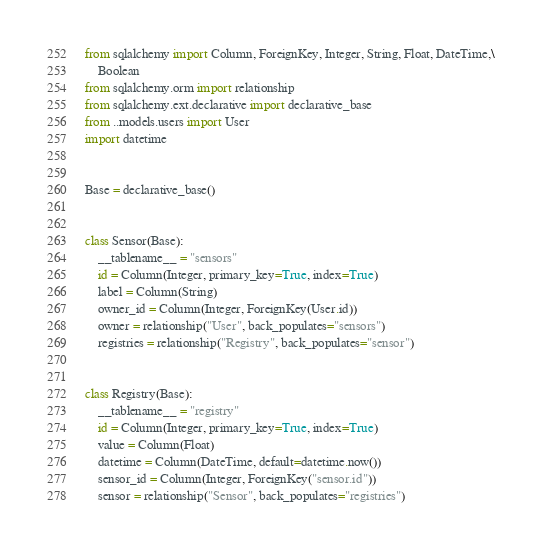Convert code to text. <code><loc_0><loc_0><loc_500><loc_500><_Python_>from sqlalchemy import Column, ForeignKey, Integer, String, Float, DateTime,\
    Boolean
from sqlalchemy.orm import relationship
from sqlalchemy.ext.declarative import declarative_base
from ..models.users import User
import datetime


Base = declarative_base()


class Sensor(Base):
    __tablename__ = "sensors"
    id = Column(Integer, primary_key=True, index=True)
    label = Column(String)
    owner_id = Column(Integer, ForeignKey(User.id))
    owner = relationship("User", back_populates="sensors")
    registries = relationship("Registry", back_populates="sensor")


class Registry(Base):
    __tablename__ = "registry"
    id = Column(Integer, primary_key=True, index=True)
    value = Column(Float)
    datetime = Column(DateTime, default=datetime.now())
    sensor_id = Column(Integer, ForeignKey("sensor.id"))
    sensor = relationship("Sensor", back_populates="registries")
</code> 